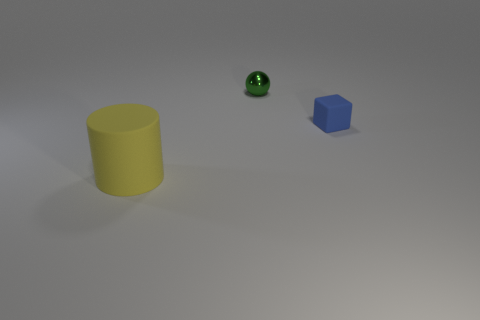Is there a shiny thing?
Your answer should be compact. Yes. There is a rubber thing that is in front of the rubber object that is behind the big yellow thing; what is its size?
Keep it short and to the point. Large. Are there any small objects made of the same material as the yellow cylinder?
Keep it short and to the point. Yes. What material is the green sphere that is the same size as the blue rubber block?
Offer a very short reply. Metal. Does the small thing that is to the left of the tiny blue cube have the same color as the matte thing in front of the tiny blue cube?
Keep it short and to the point. No. There is a thing in front of the tiny blue rubber thing; are there any tiny blue matte objects that are to the right of it?
Offer a very short reply. Yes. Is the material of the thing that is behind the blue object the same as the object in front of the small blue block?
Provide a short and direct response. No. There is a tiny object that is behind the tiny object that is in front of the tiny metallic ball; what is it made of?
Give a very brief answer. Metal. What is the shape of the tiny thing that is behind the rubber thing behind the thing left of the small green metal object?
Ensure brevity in your answer.  Sphere. What number of large green cubes are there?
Your answer should be compact. 0. 